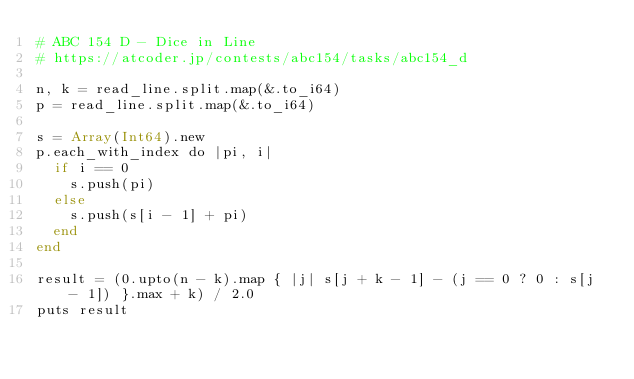Convert code to text. <code><loc_0><loc_0><loc_500><loc_500><_Crystal_># ABC 154 D - Dice in Line
# https://atcoder.jp/contests/abc154/tasks/abc154_d

n, k = read_line.split.map(&.to_i64)
p = read_line.split.map(&.to_i64)

s = Array(Int64).new
p.each_with_index do |pi, i|
  if i == 0
    s.push(pi)
  else
    s.push(s[i - 1] + pi)
  end
end

result = (0.upto(n - k).map { |j| s[j + k - 1] - (j == 0 ? 0 : s[j - 1]) }.max + k) / 2.0
puts result
</code> 